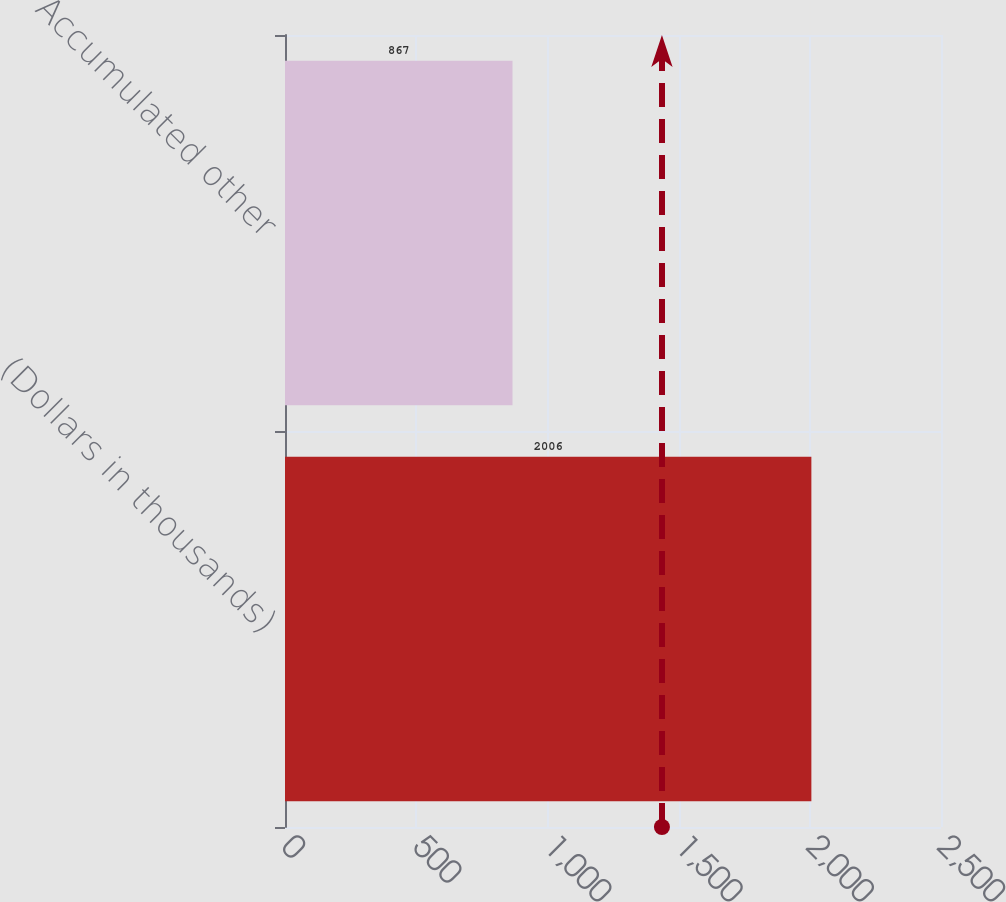Convert chart. <chart><loc_0><loc_0><loc_500><loc_500><bar_chart><fcel>(Dollars in thousands)<fcel>Accumulated other<nl><fcel>2006<fcel>867<nl></chart> 